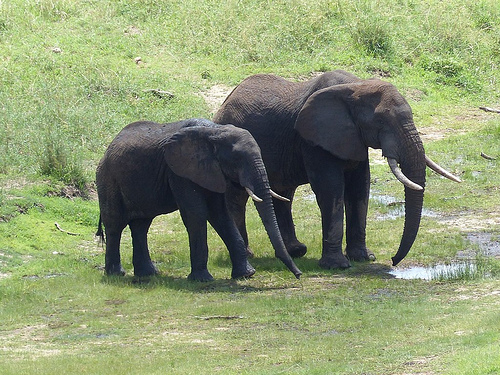What color does the dirt have? The dirt has a light brown color, blending seamlessly with the surrounding greenery. 